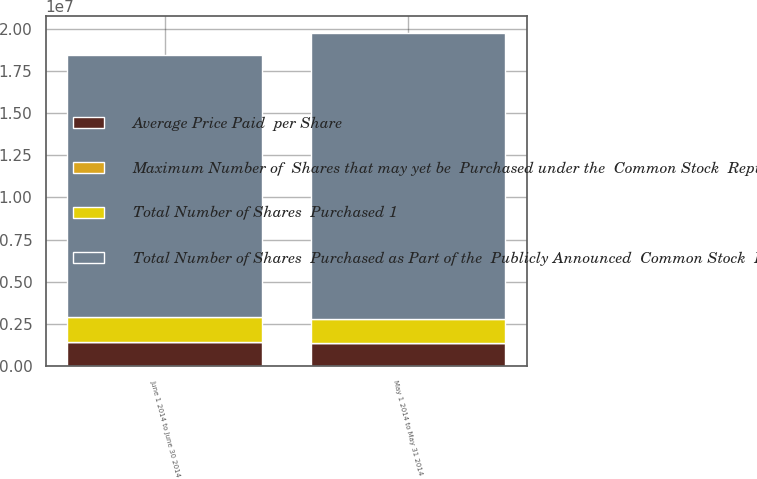Convert chart to OTSL. <chart><loc_0><loc_0><loc_500><loc_500><stacked_bar_chart><ecel><fcel>May 1 2014 to May 31 2014<fcel>June 1 2014 to June 30 2014<nl><fcel>Average Price Paid  per Share<fcel>1.40289e+06<fcel>1.46257e+06<nl><fcel>Maximum Number of  Shares that may yet be  Purchased under the  Common Stock  Repurchase Plan 2  3<fcel>78.19<fcel>79<nl><fcel>Total Number of Shares  Purchased 1<fcel>1.4e+06<fcel>1.46205e+06<nl><fcel>Total Number of Shares  Purchased as Part of the  Publicly Announced  Common Stock  Repurchase Plan 2<fcel>1.69517e+07<fcel>1.54896e+07<nl></chart> 